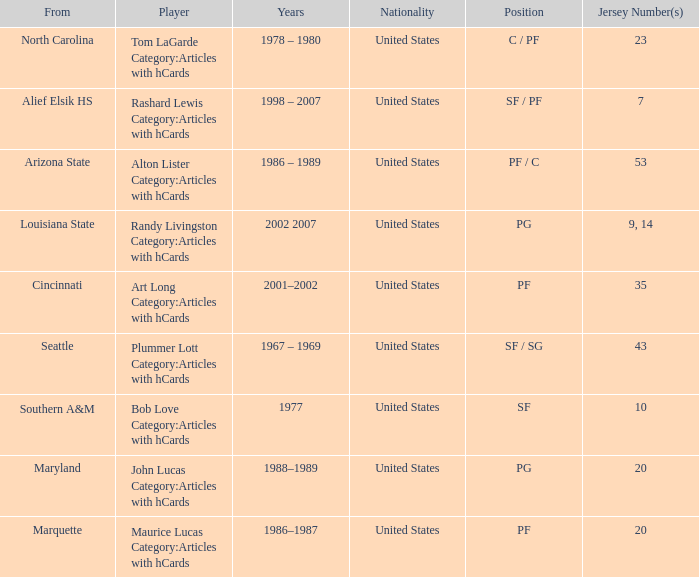Bob Love Category:Articles with hCards is from where? Southern A&M. 